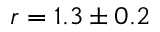<formula> <loc_0><loc_0><loc_500><loc_500>r = 1 . 3 \pm 0 . 2</formula> 